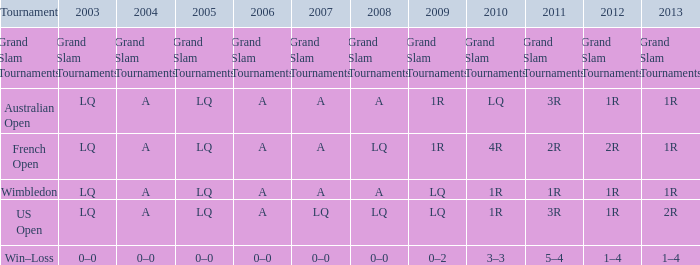Which year possesses a 2011 of 1r? A. 